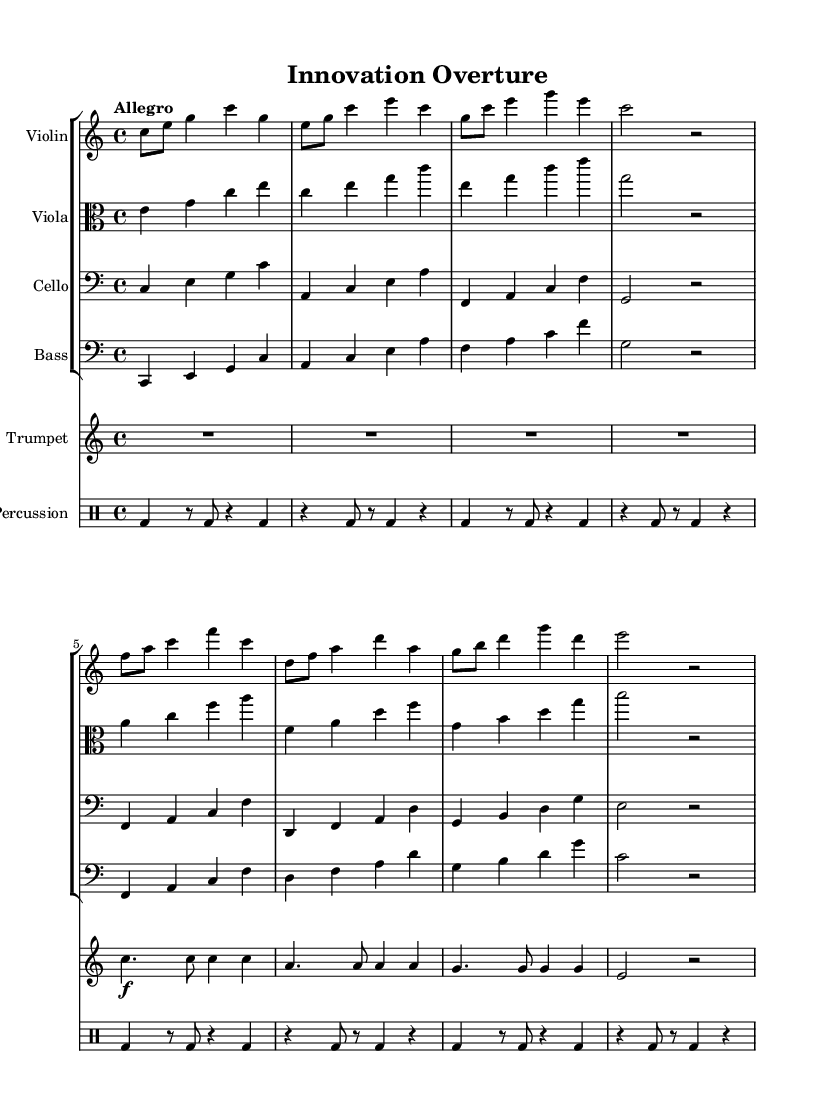What is the key signature of this music? The key signature appears at the beginning of the score and indicates C major, which has no sharp or flat notes.
Answer: C major What is the time signature of this music? The time signature is found at the start of the score and shows that the music is in 4/4 time, meaning there are four beats in each measure.
Answer: 4/4 What is the tempo marking given in the score? The tempo marking is indicated above the staff and specifies that the piece should be played "Allegro," which means fast or lively.
Answer: Allegro How many different instruments are present in the score? By counting the staff groups, we recognize four string instruments (Violin, Viola, Cello, Bass), one trumpet, and one percussion part, totaling six instruments.
Answer: Six instruments What is the dynamic marking for the trumpet in the first measure? The dynamic marking is shown as "f," indicating that the trumpet should be played loudly or with force in the first measure.
Answer: f Which part plays a rest in the first measure? The percussion part is denoted by a rest on the first beat of the first measure, indicating silence for that instrument in that moment.
Answer: Percussion 